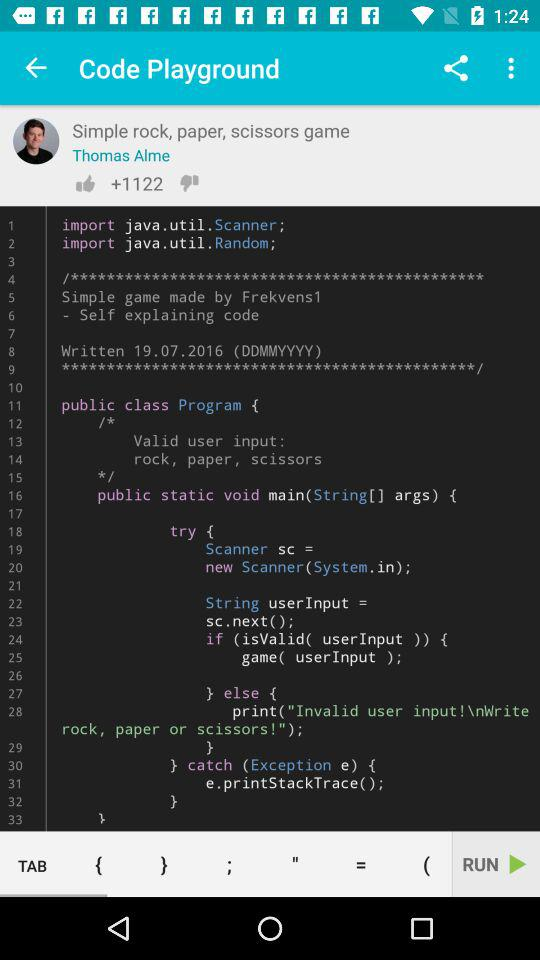How many likes are there? There are 1122 likes. 